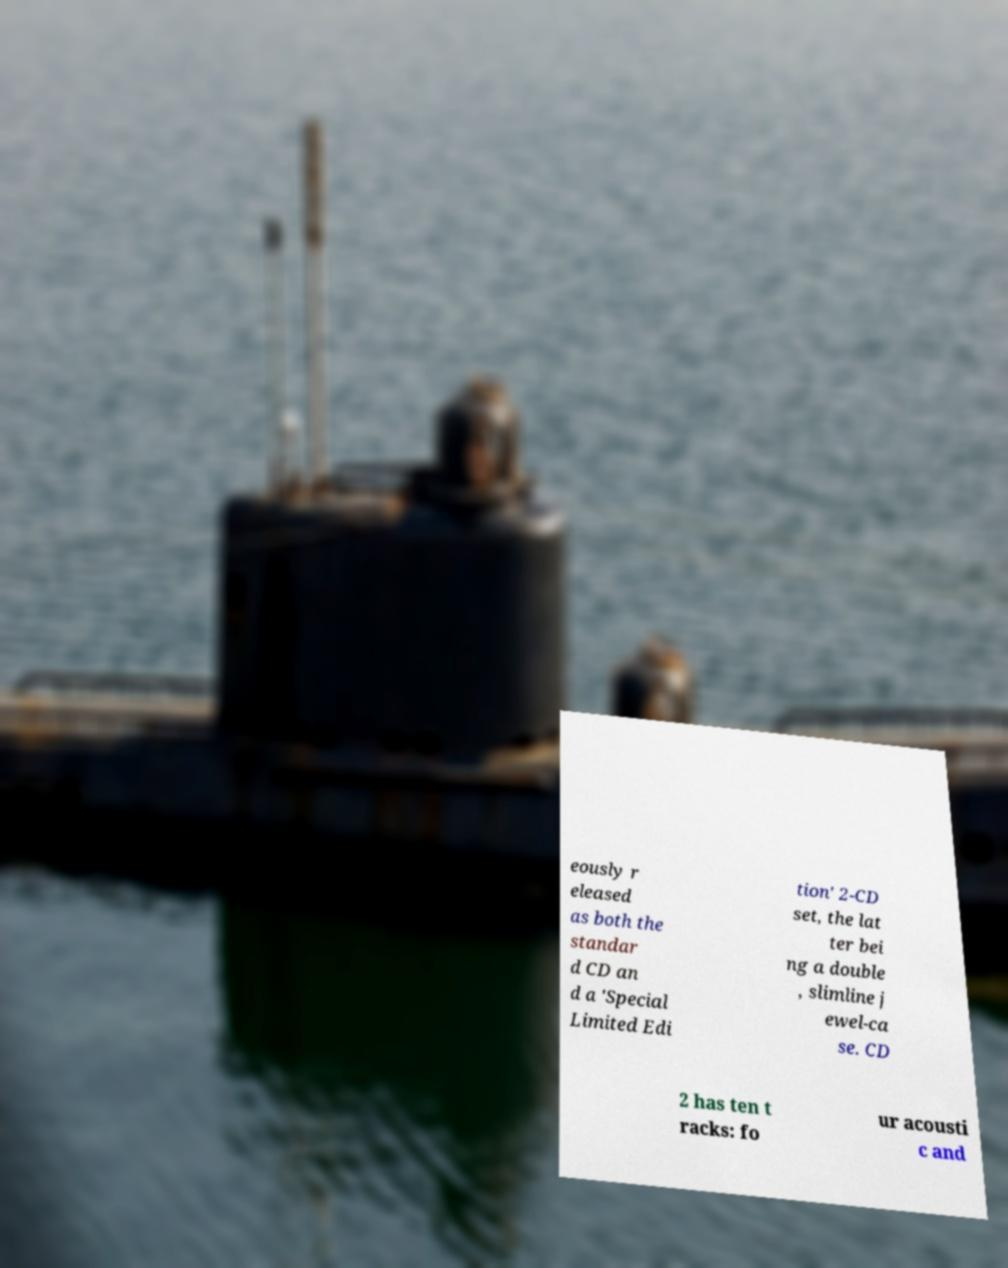I need the written content from this picture converted into text. Can you do that? eously r eleased as both the standar d CD an d a 'Special Limited Edi tion' 2-CD set, the lat ter bei ng a double , slimline j ewel-ca se. CD 2 has ten t racks: fo ur acousti c and 